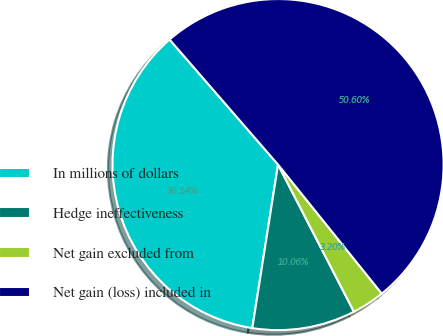<chart> <loc_0><loc_0><loc_500><loc_500><pie_chart><fcel>In millions of dollars<fcel>Hedge ineffectiveness<fcel>Net gain excluded from<fcel>Net gain (loss) included in<nl><fcel>36.14%<fcel>10.06%<fcel>3.2%<fcel>50.59%<nl></chart> 